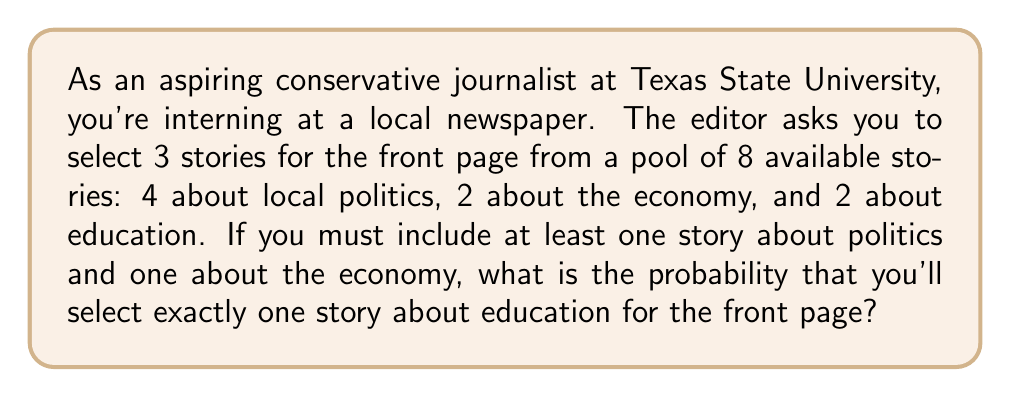Can you answer this question? Let's approach this step-by-step:

1) We need to select 3 stories in total, with at least one about politics and one about the economy, and we want to know the probability of selecting exactly one about education.

2) To calculate this, we'll use the concept of favorable outcomes divided by total outcomes.

3) First, let's count the total number of ways to select 3 stories with at least one about politics and one about the economy:
   - Select 1 politics story: $\binom{4}{1}$
   - Select 1 economy story: $\binom{2}{1}$
   - Select 1 from the remaining 6 stories: $\binom{6}{1}$

   Total combinations: $\binom{4}{1} \cdot \binom{2}{1} \cdot \binom{6}{1} = 4 \cdot 2 \cdot 6 = 48$

4) Now, let's count the favorable outcomes (exactly one education story):
   - Select 1 politics story: $\binom{4}{1}$
   - Select 1 economy story: $\binom{2}{1}$
   - Select 1 education story: $\binom{2}{1}$

   Favorable combinations: $\binom{4}{1} \cdot \binom{2}{1} \cdot \binom{2}{1} = 4 \cdot 2 \cdot 2 = 16$

5) The probability is therefore:

   $$P(\text{exactly one education story}) = \frac{\text{favorable outcomes}}{\text{total outcomes}} = \frac{16}{48} = \frac{1}{3}$$
Answer: $\frac{1}{3}$ or approximately $0.3333$ 